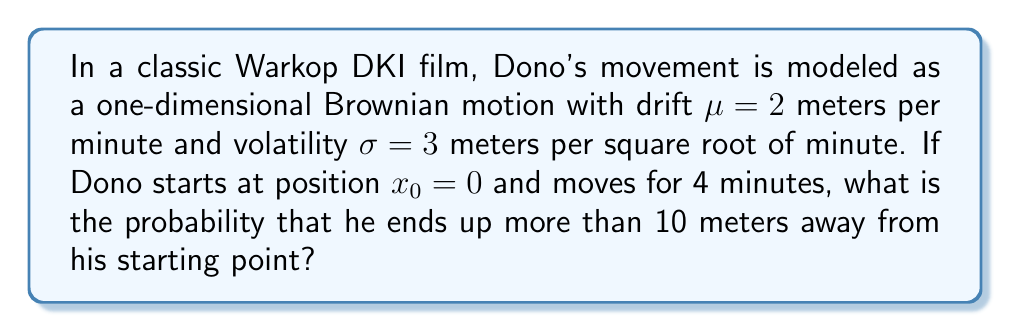Teach me how to tackle this problem. Let's approach this step-by-step:

1) In Brownian motion with drift, the position $X_t$ at time $t$ is normally distributed with mean $\mu t$ and variance $\sigma^2 t$. 

2) After 4 minutes, Dono's position $X_4$ will be normally distributed with:
   Mean: $E[X_4] = \mu t = 2 \cdot 4 = 8$ meters
   Variance: $Var[X_4] = \sigma^2 t = 3^2 \cdot 4 = 36$ square meters

3) We need to find $P(|X_4 - x_0| > 10)$, which is equivalent to $P(X_4 > 10) + P(X_4 < -10)$

4) Let's standardize the normal distribution:
   $Z = \frac{X_4 - E[X_4]}{\sqrt{Var[X_4]}} = \frac{X_4 - 8}{6}$

5) Now we need to calculate:
   $P(Z > \frac{10-8}{6}) + P(Z < \frac{-10-8}{6})$
   $= P(Z > \frac{1}{3}) + P(Z < -3)$

6) Using the standard normal distribution table or calculator:
   $P(Z > \frac{1}{3}) \approx 0.3707$
   $P(Z < -3) \approx 0.0013$

7) The total probability is:
   $0.3707 + 0.0013 = 0.3720$

Therefore, the probability that Dono ends up more than 10 meters away from his starting point after 4 minutes is approximately 0.3720 or 37.20%.
Answer: 0.3720 